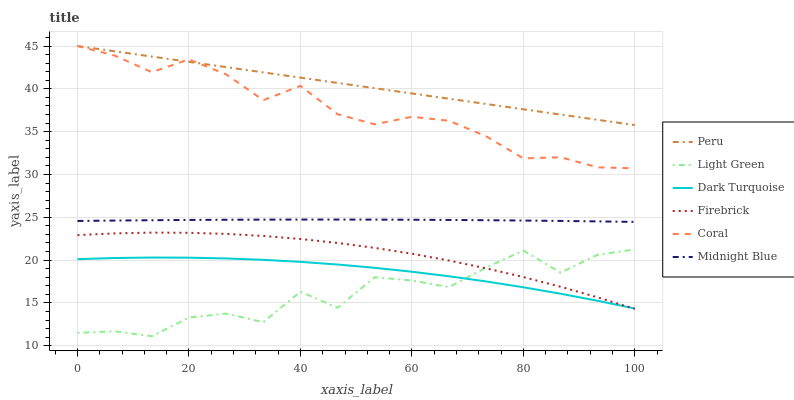Does Light Green have the minimum area under the curve?
Answer yes or no. Yes. Does Peru have the maximum area under the curve?
Answer yes or no. Yes. Does Dark Turquoise have the minimum area under the curve?
Answer yes or no. No. Does Dark Turquoise have the maximum area under the curve?
Answer yes or no. No. Is Peru the smoothest?
Answer yes or no. Yes. Is Light Green the roughest?
Answer yes or no. Yes. Is Dark Turquoise the smoothest?
Answer yes or no. No. Is Dark Turquoise the roughest?
Answer yes or no. No. Does Light Green have the lowest value?
Answer yes or no. Yes. Does Dark Turquoise have the lowest value?
Answer yes or no. No. Does Coral have the highest value?
Answer yes or no. Yes. Does Dark Turquoise have the highest value?
Answer yes or no. No. Is Firebrick less than Coral?
Answer yes or no. Yes. Is Midnight Blue greater than Light Green?
Answer yes or no. Yes. Does Dark Turquoise intersect Firebrick?
Answer yes or no. Yes. Is Dark Turquoise less than Firebrick?
Answer yes or no. No. Is Dark Turquoise greater than Firebrick?
Answer yes or no. No. Does Firebrick intersect Coral?
Answer yes or no. No. 